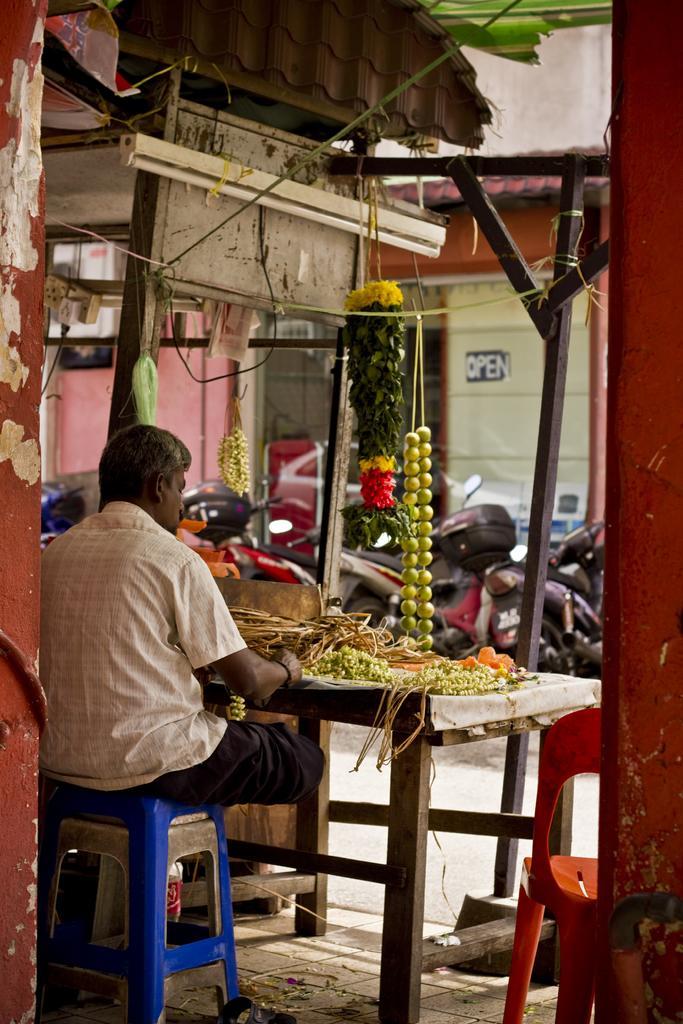Could you give a brief overview of what you see in this image? In this picture on the left side, we can see a person sitting in front of the table. On that table, we can see some flowers and grass. On the right side, we can also see a chair. In the background, we can see some garlands, bikes, cars, glass doors, wall. 